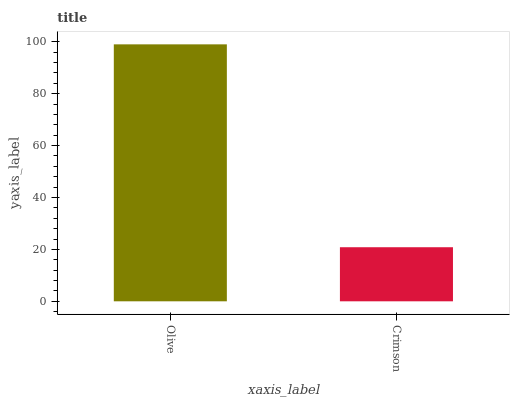Is Crimson the maximum?
Answer yes or no. No. Is Olive greater than Crimson?
Answer yes or no. Yes. Is Crimson less than Olive?
Answer yes or no. Yes. Is Crimson greater than Olive?
Answer yes or no. No. Is Olive less than Crimson?
Answer yes or no. No. Is Olive the high median?
Answer yes or no. Yes. Is Crimson the low median?
Answer yes or no. Yes. Is Crimson the high median?
Answer yes or no. No. Is Olive the low median?
Answer yes or no. No. 